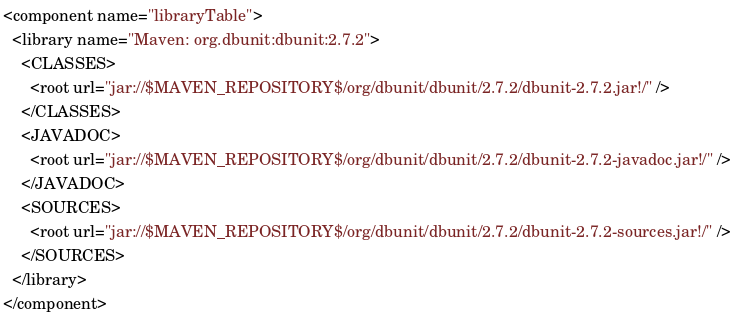<code> <loc_0><loc_0><loc_500><loc_500><_XML_><component name="libraryTable">
  <library name="Maven: org.dbunit:dbunit:2.7.2">
    <CLASSES>
      <root url="jar://$MAVEN_REPOSITORY$/org/dbunit/dbunit/2.7.2/dbunit-2.7.2.jar!/" />
    </CLASSES>
    <JAVADOC>
      <root url="jar://$MAVEN_REPOSITORY$/org/dbunit/dbunit/2.7.2/dbunit-2.7.2-javadoc.jar!/" />
    </JAVADOC>
    <SOURCES>
      <root url="jar://$MAVEN_REPOSITORY$/org/dbunit/dbunit/2.7.2/dbunit-2.7.2-sources.jar!/" />
    </SOURCES>
  </library>
</component></code> 